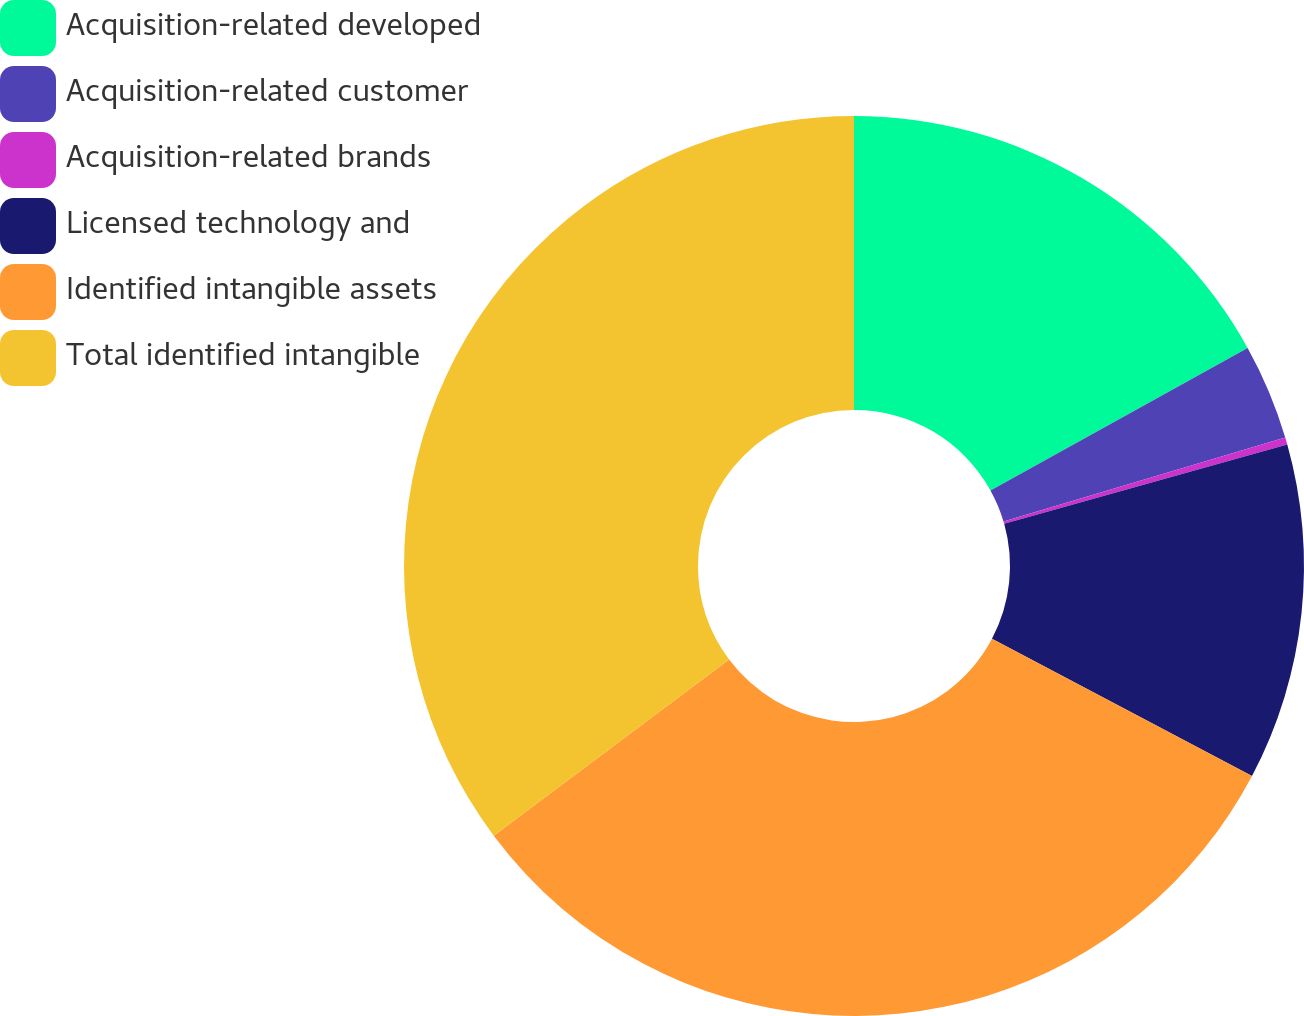Convert chart. <chart><loc_0><loc_0><loc_500><loc_500><pie_chart><fcel>Acquisition-related developed<fcel>Acquisition-related customer<fcel>Acquisition-related brands<fcel>Licensed technology and<fcel>Identified intangible assets<fcel>Total identified intangible<nl><fcel>16.95%<fcel>3.44%<fcel>0.26%<fcel>12.08%<fcel>32.05%<fcel>35.23%<nl></chart> 